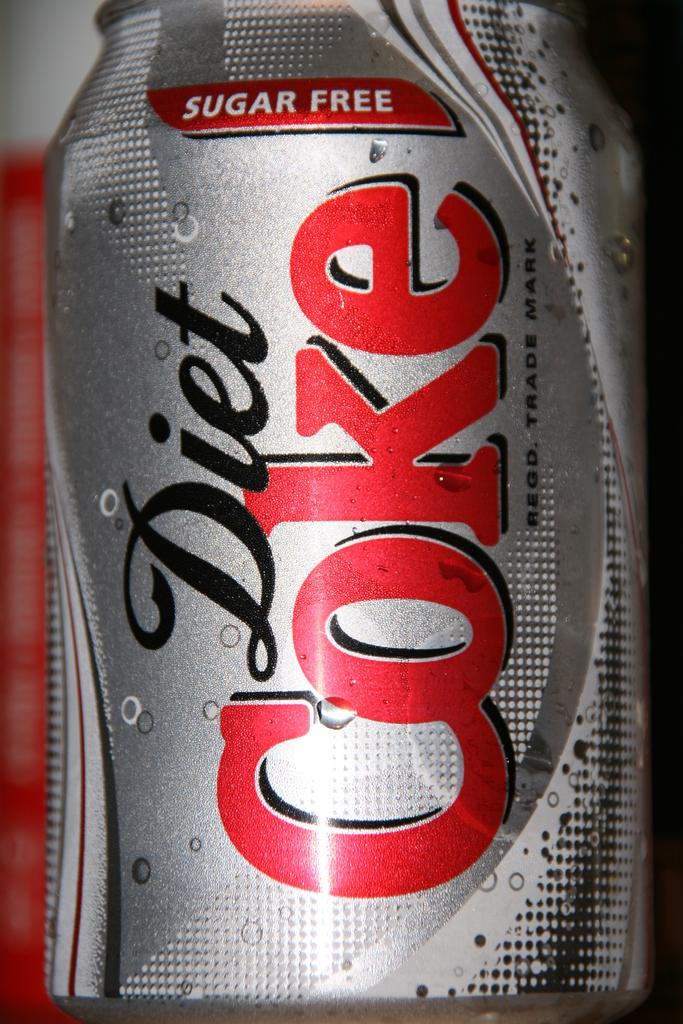<image>
Render a clear and concise summary of the photo. a Diet Coke can that is gray and red 